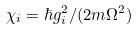Convert formula to latex. <formula><loc_0><loc_0><loc_500><loc_500>\chi _ { i } = \hbar { g } _ { i } ^ { 2 } / ( 2 m \Omega ^ { 2 } )</formula> 